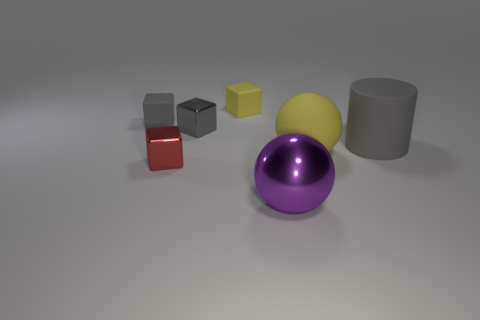Subtract all green balls. How many gray cubes are left? 2 Add 3 big yellow spheres. How many objects exist? 10 Subtract all small yellow blocks. How many blocks are left? 3 Subtract 2 cubes. How many cubes are left? 2 Subtract all red blocks. How many blocks are left? 3 Subtract all balls. How many objects are left? 5 Subtract all big cyan spheres. Subtract all tiny rubber blocks. How many objects are left? 5 Add 4 gray metal cubes. How many gray metal cubes are left? 5 Add 6 small rubber cylinders. How many small rubber cylinders exist? 6 Subtract 0 green blocks. How many objects are left? 7 